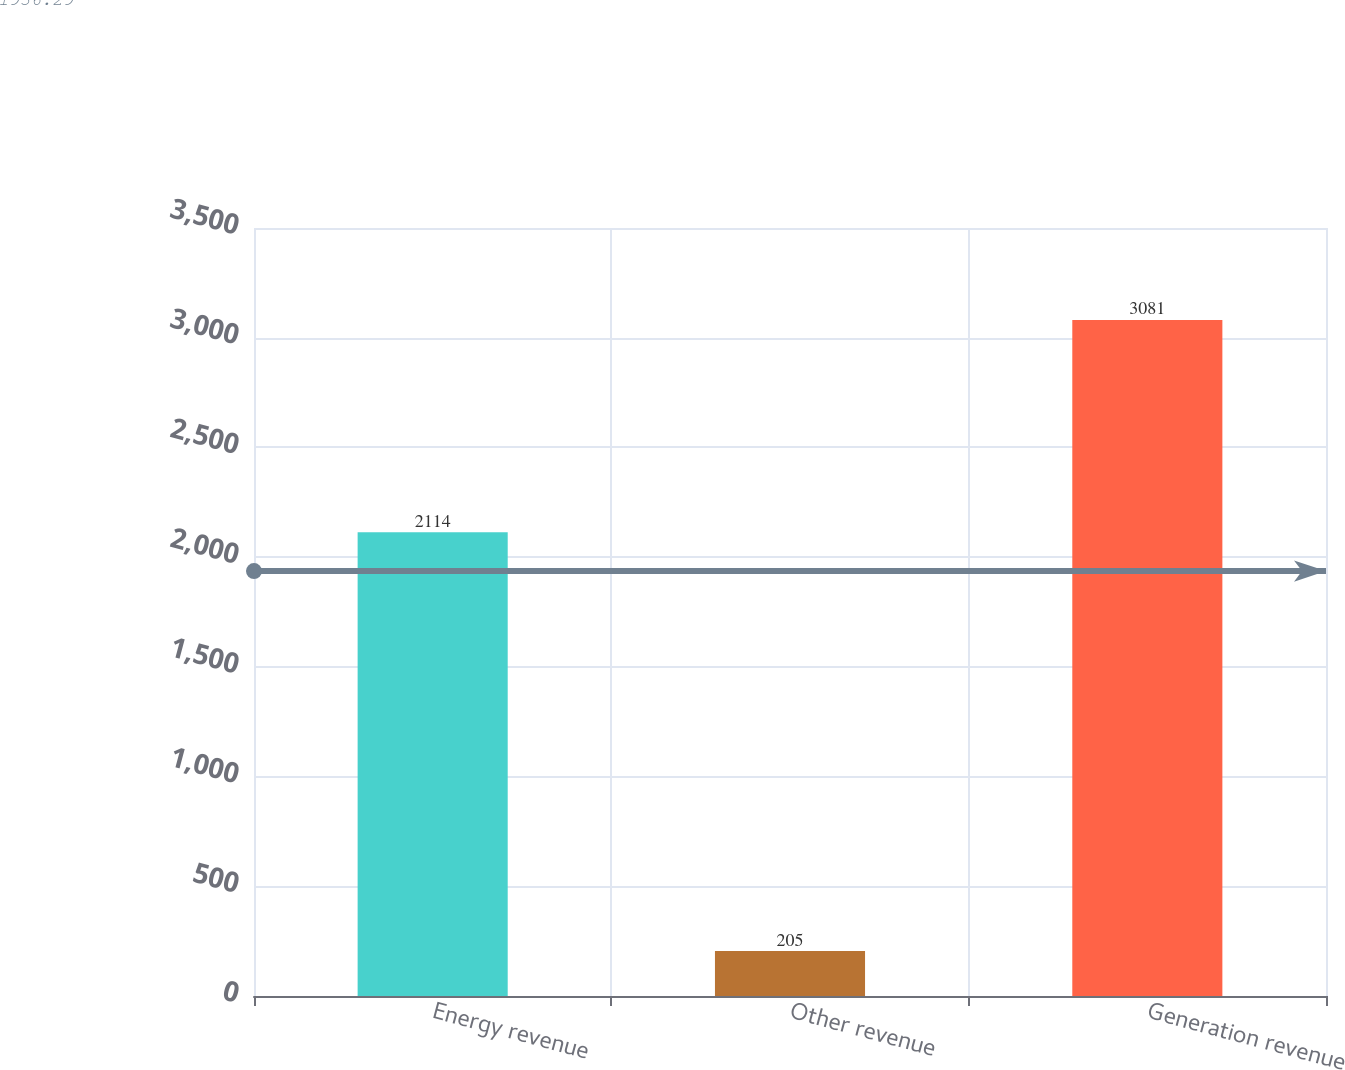Convert chart to OTSL. <chart><loc_0><loc_0><loc_500><loc_500><bar_chart><fcel>Energy revenue<fcel>Other revenue<fcel>Generation revenue<nl><fcel>2114<fcel>205<fcel>3081<nl></chart> 